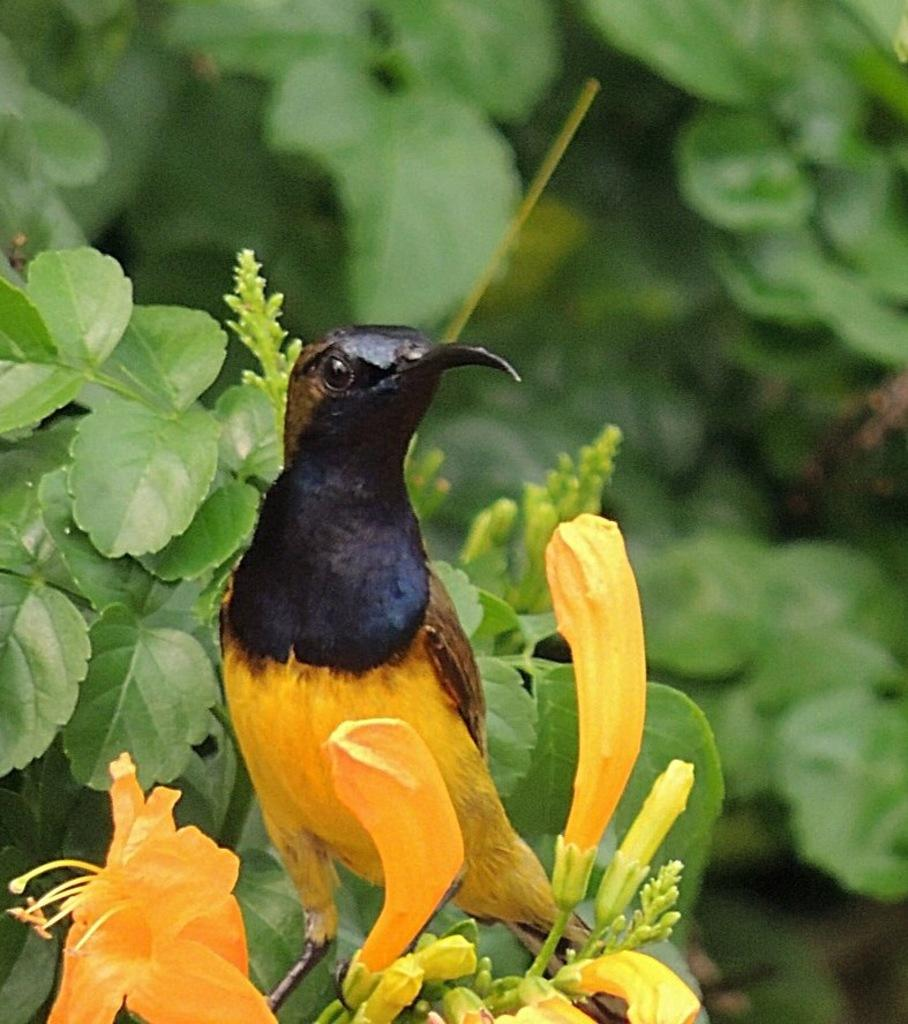What type of animal is in the image? There is a bird in the image. Can you describe the bird's coloring? The bird has yellow and black coloring. What can be seen in the foreground of the image? There are yellow color flowers in the foreground of the image. What is visible in the background of the image? There are leaves and trees in the background of the image. How many flowers are in the rod that the bird is holding in the image? There is no rod or flowers held by the bird in the image. The bird is simply perched among the leaves and trees. 